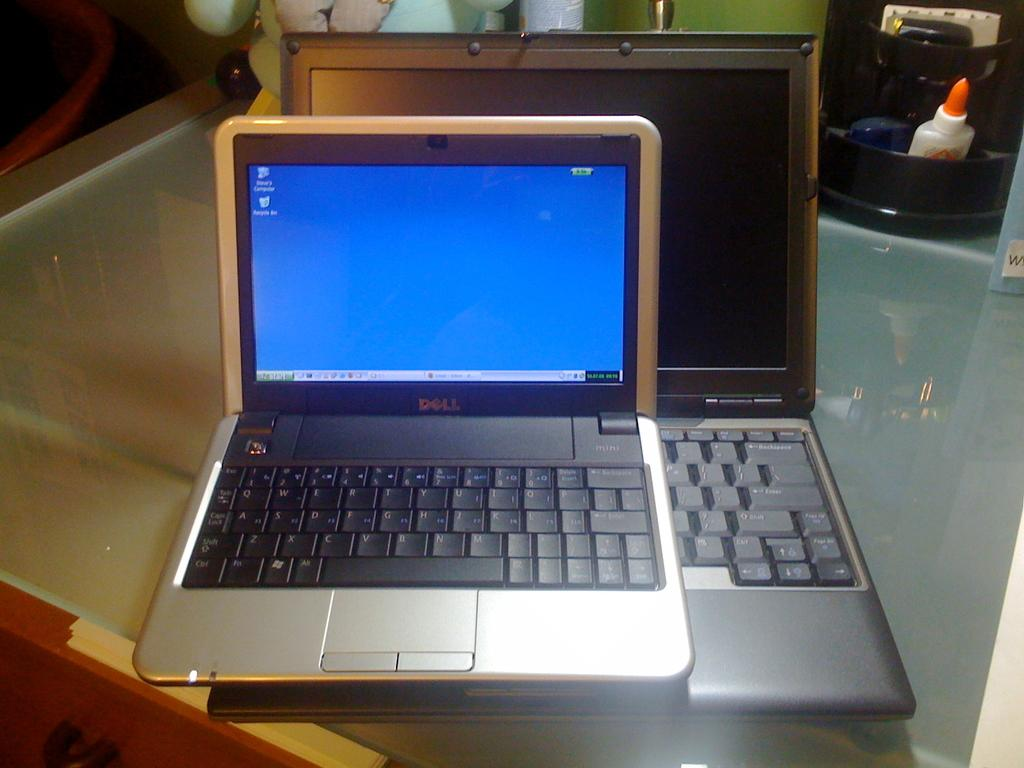<image>
Give a short and clear explanation of the subsequent image. A small dell laptop which is turned on sits on a larger laptop which is switched off. 